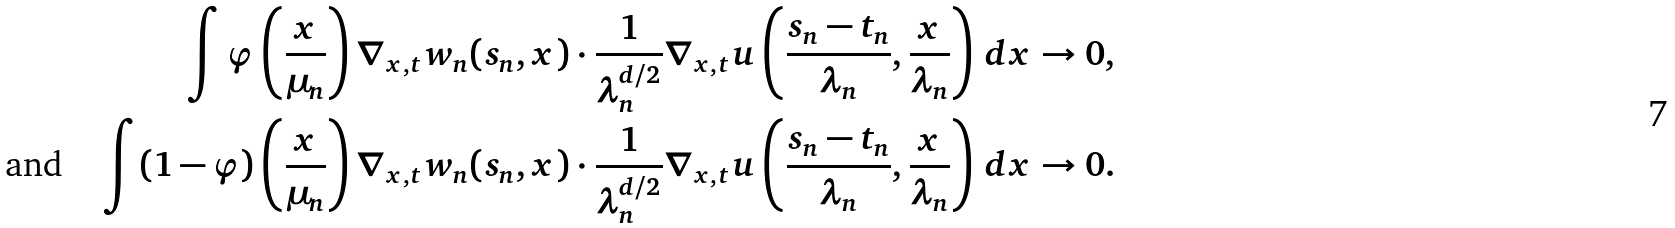Convert formula to latex. <formula><loc_0><loc_0><loc_500><loc_500>\int \varphi \left ( \frac { x } { \mu _ { n } } \right ) \nabla _ { x , t } w _ { n } ( s _ { n } , x ) \cdot \frac { 1 } { \lambda _ { n } ^ { d / 2 } } \nabla _ { x , t } u \left ( \frac { s _ { n } - t _ { n } } { \lambda _ { n } } , \frac { x } { \lambda _ { n } } \right ) \, d x & \to 0 , \\ \text {and} \quad \int ( 1 - \varphi ) \left ( \frac { x } { \mu _ { n } } \right ) \nabla _ { x , t } w _ { n } ( s _ { n } , x ) \cdot \frac { 1 } { \lambda _ { n } ^ { d / 2 } } \nabla _ { x , t } u \left ( \frac { s _ { n } - t _ { n } } { \lambda _ { n } } , \frac { x } { \lambda _ { n } } \right ) \, d x & \to 0 .</formula> 